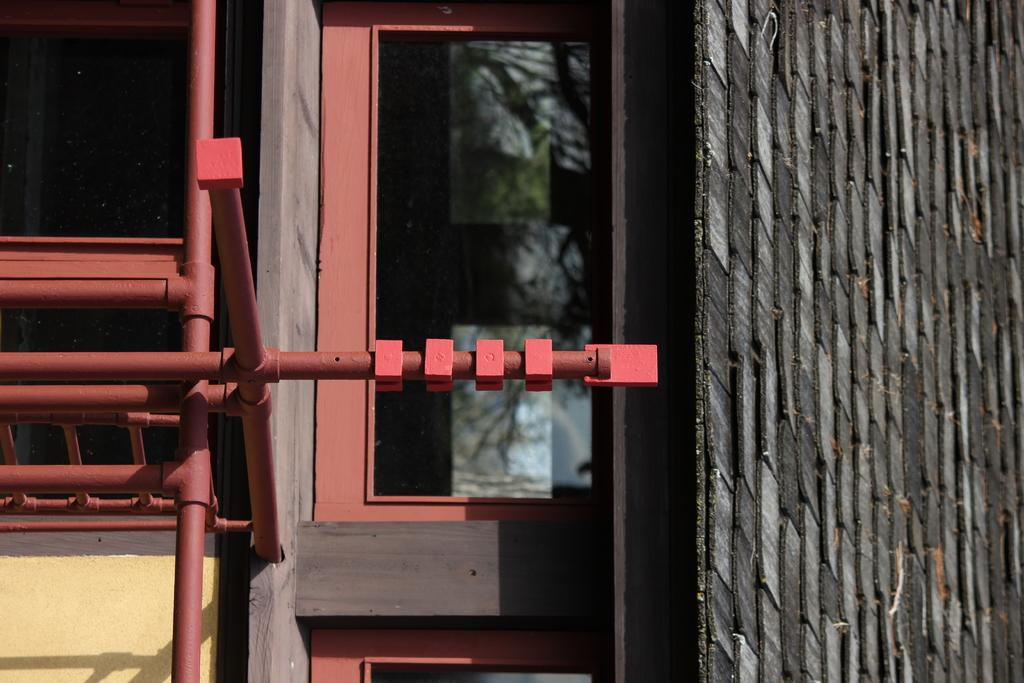What type of structure is visible in the image? There is a house in the image. What features can be seen on the house? The house has windows and a roof. What else is present in the image besides the house? There are metal poles in the image. Where is the dock located in the image? There is no dock present in the image. What type of wine is being served in the image? There is no wine present in the image. 